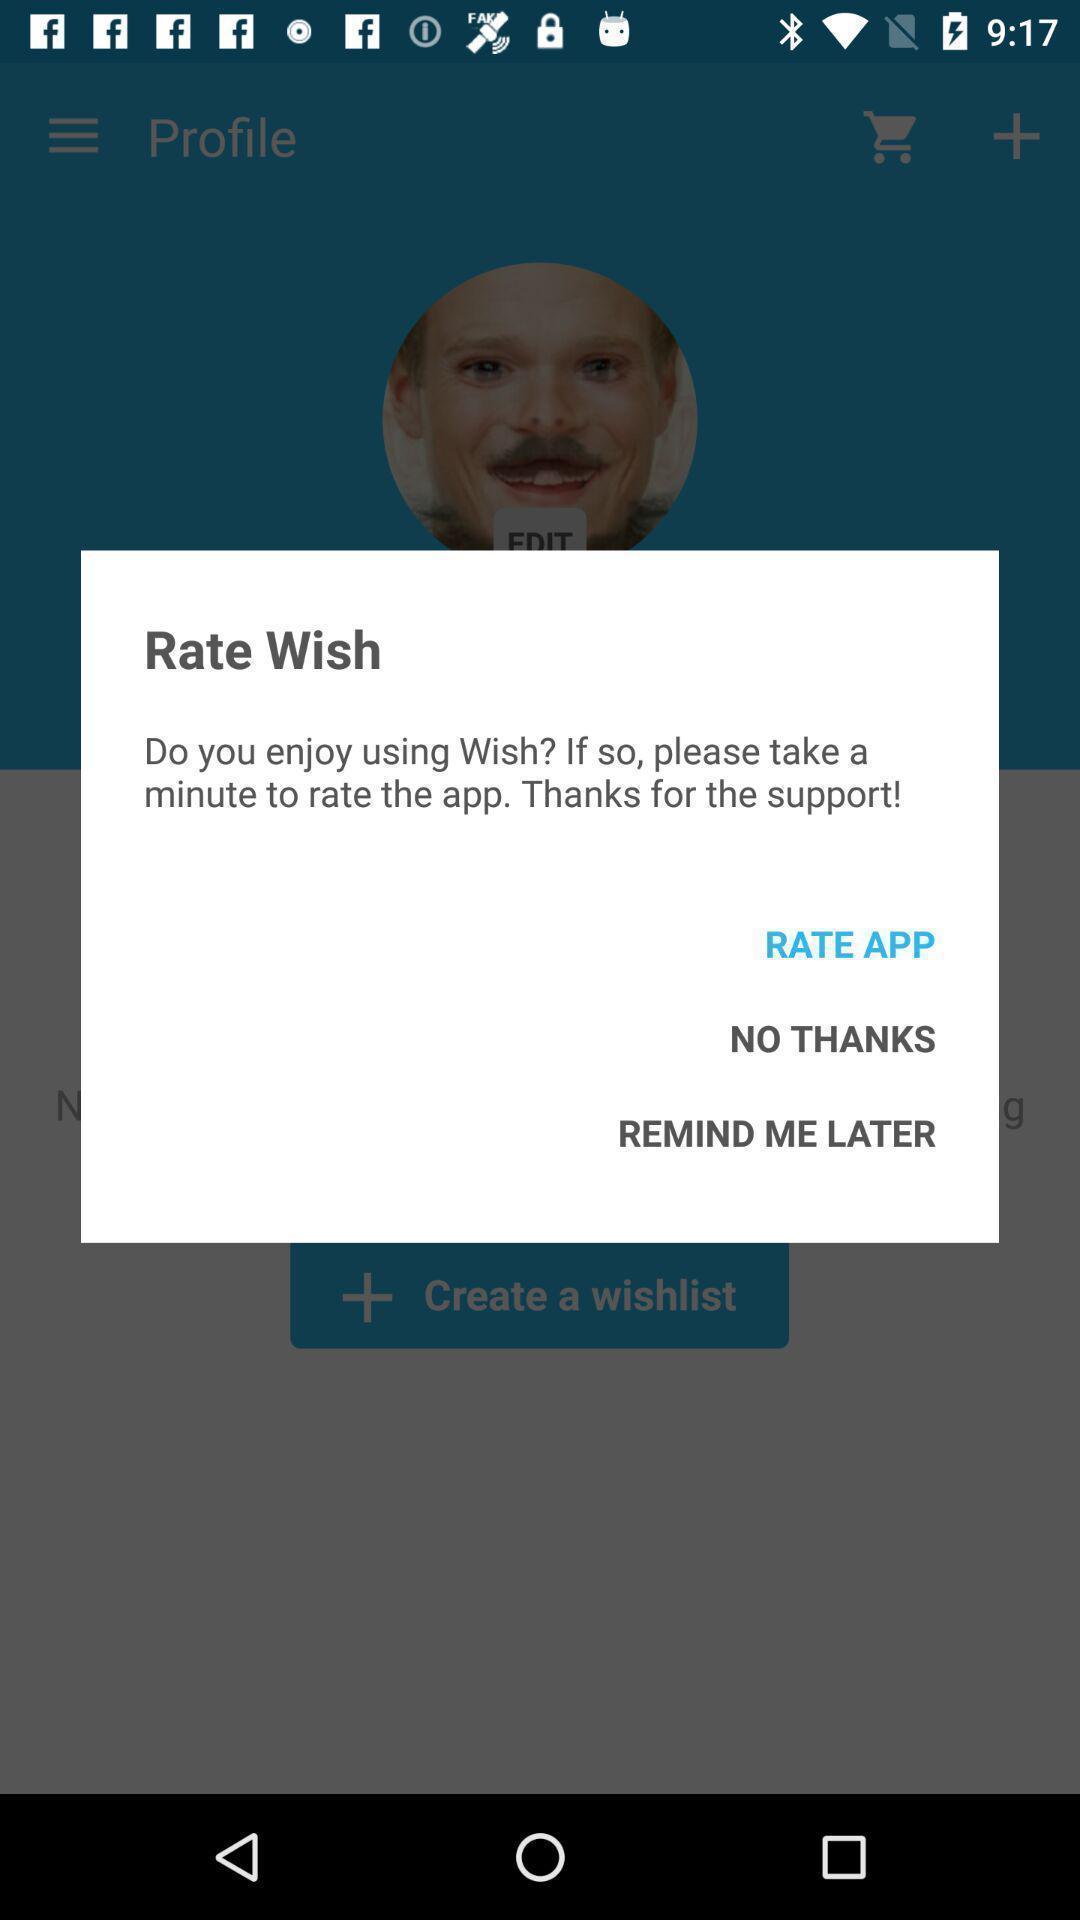Tell me about the visual elements in this screen capture. Pop-up displaying to rate the app. 